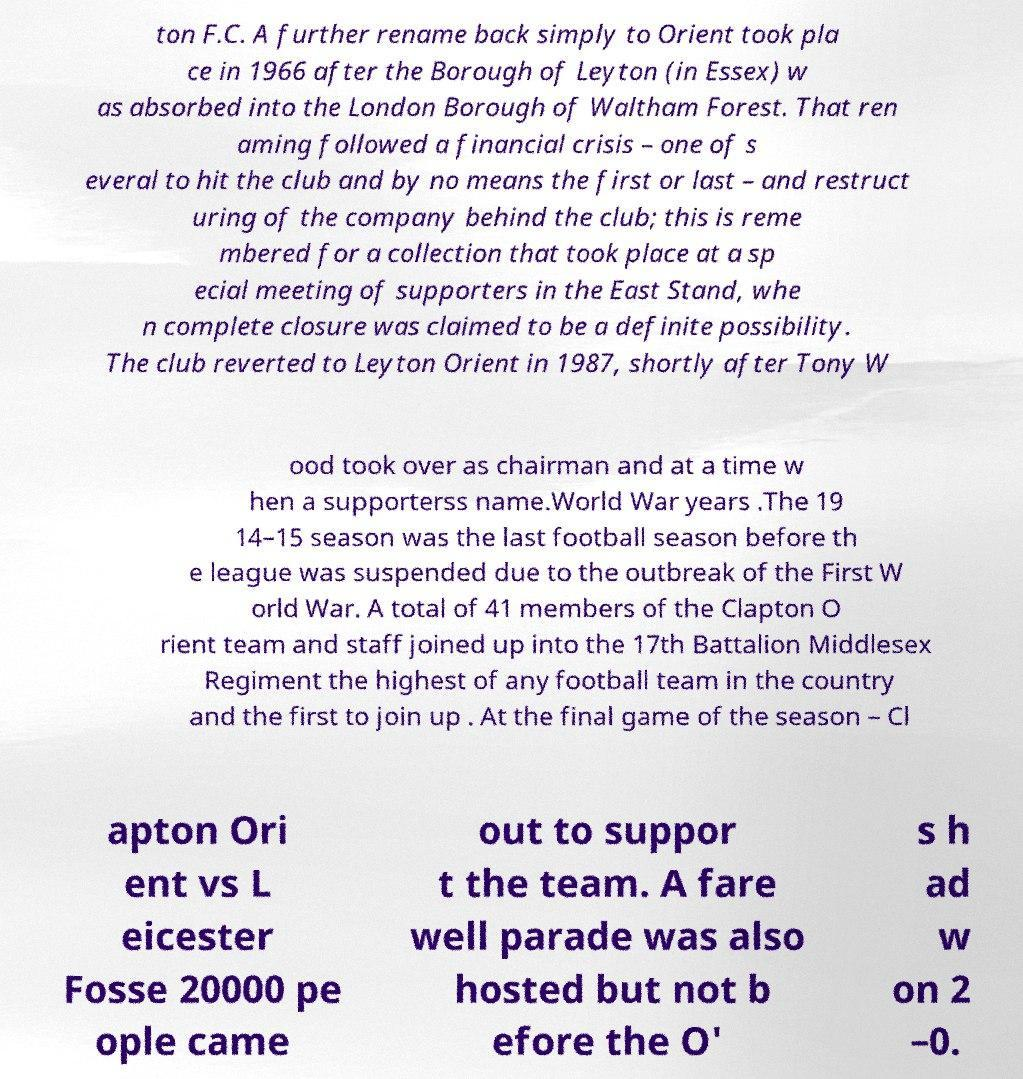Please read and relay the text visible in this image. What does it say? ton F.C. A further rename back simply to Orient took pla ce in 1966 after the Borough of Leyton (in Essex) w as absorbed into the London Borough of Waltham Forest. That ren aming followed a financial crisis – one of s everal to hit the club and by no means the first or last – and restruct uring of the company behind the club; this is reme mbered for a collection that took place at a sp ecial meeting of supporters in the East Stand, whe n complete closure was claimed to be a definite possibility. The club reverted to Leyton Orient in 1987, shortly after Tony W ood took over as chairman and at a time w hen a supporterss name.World War years .The 19 14–15 season was the last football season before th e league was suspended due to the outbreak of the First W orld War. A total of 41 members of the Clapton O rient team and staff joined up into the 17th Battalion Middlesex Regiment the highest of any football team in the country and the first to join up . At the final game of the season – Cl apton Ori ent vs L eicester Fosse 20000 pe ople came out to suppor t the team. A fare well parade was also hosted but not b efore the O' s h ad w on 2 –0. 